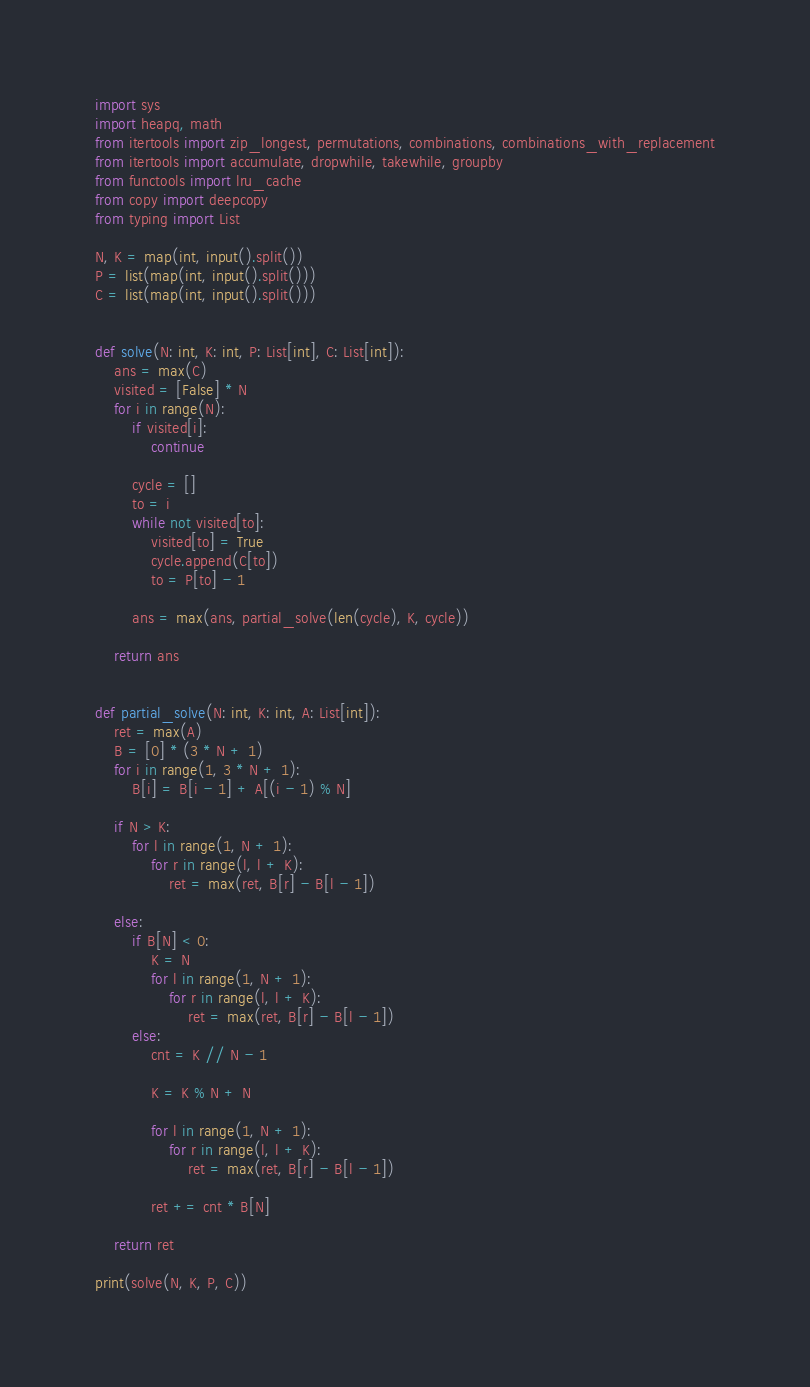Convert code to text. <code><loc_0><loc_0><loc_500><loc_500><_Python_>import sys
import heapq, math
from itertools import zip_longest, permutations, combinations, combinations_with_replacement
from itertools import accumulate, dropwhile, takewhile, groupby
from functools import lru_cache
from copy import deepcopy
from typing import List

N, K = map(int, input().split())
P = list(map(int, input().split()))
C = list(map(int, input().split()))


def solve(N: int, K: int, P: List[int], C: List[int]):
    ans = max(C)
    visited = [False] * N
    for i in range(N):
        if visited[i]:
            continue

        cycle = []
        to = i
        while not visited[to]:
            visited[to] = True
            cycle.append(C[to])
            to = P[to] - 1

        ans = max(ans, partial_solve(len(cycle), K, cycle))

    return ans


def partial_solve(N: int, K: int, A: List[int]):
    ret = max(A)
    B = [0] * (3 * N + 1)
    for i in range(1, 3 * N + 1):
        B[i] = B[i - 1] + A[(i - 1) % N]

    if N > K:
        for l in range(1, N + 1):
            for r in range(l, l + K):
                ret = max(ret, B[r] - B[l - 1])

    else:
        if B[N] < 0:
            K = N
            for l in range(1, N + 1):
                for r in range(l, l + K):
                    ret = max(ret, B[r] - B[l - 1])
        else:
            cnt = K // N - 1

            K = K % N + N

            for l in range(1, N + 1):
                for r in range(l, l + K):
                    ret = max(ret, B[r] - B[l - 1])

            ret += cnt * B[N]

    return ret

print(solve(N, K, P, C))
</code> 